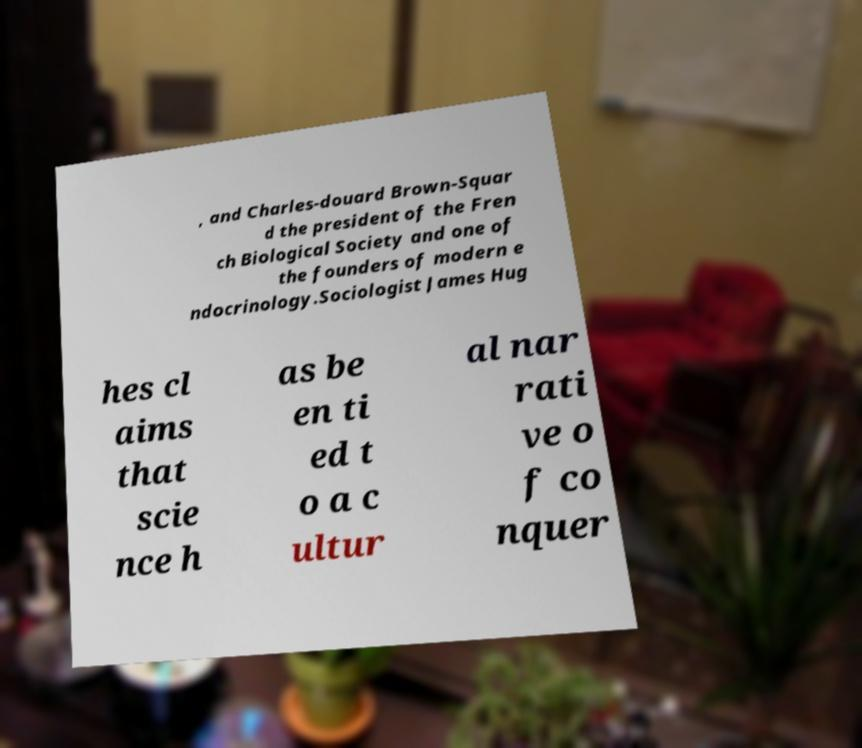I need the written content from this picture converted into text. Can you do that? , and Charles-douard Brown-Squar d the president of the Fren ch Biological Society and one of the founders of modern e ndocrinology.Sociologist James Hug hes cl aims that scie nce h as be en ti ed t o a c ultur al nar rati ve o f co nquer 